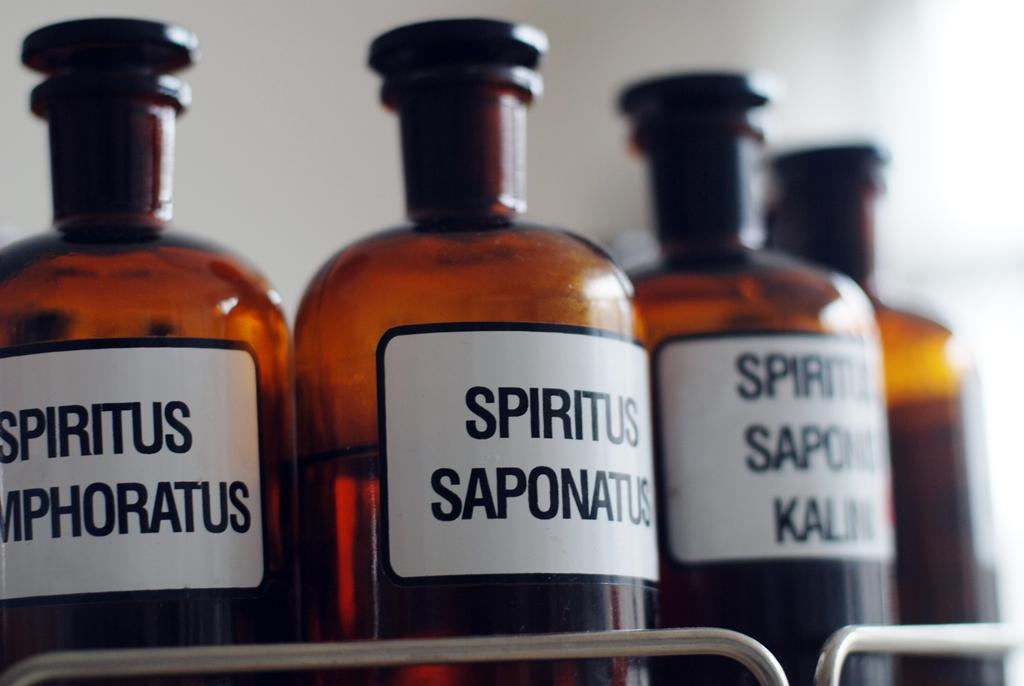<image>
Offer a succinct explanation of the picture presented. several brown bottles labelled Spiritus in a metal shelf 